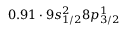Convert formula to latex. <formula><loc_0><loc_0><loc_500><loc_500>0 . 9 1 \cdot 9 s _ { 1 / 2 } ^ { 2 } 8 p _ { 3 / 2 } ^ { 1 }</formula> 